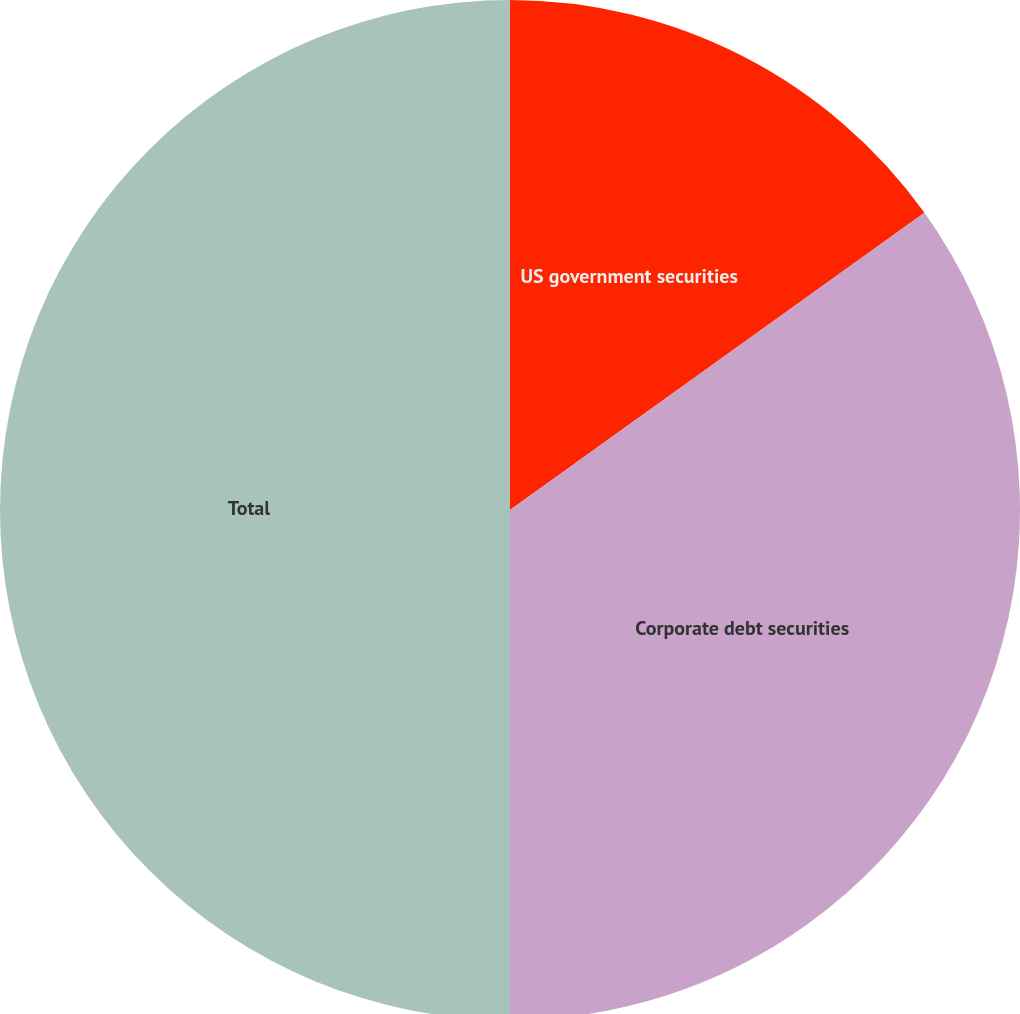<chart> <loc_0><loc_0><loc_500><loc_500><pie_chart><fcel>US government securities<fcel>Corporate debt securities<fcel>Total<nl><fcel>15.1%<fcel>34.9%<fcel>50.0%<nl></chart> 